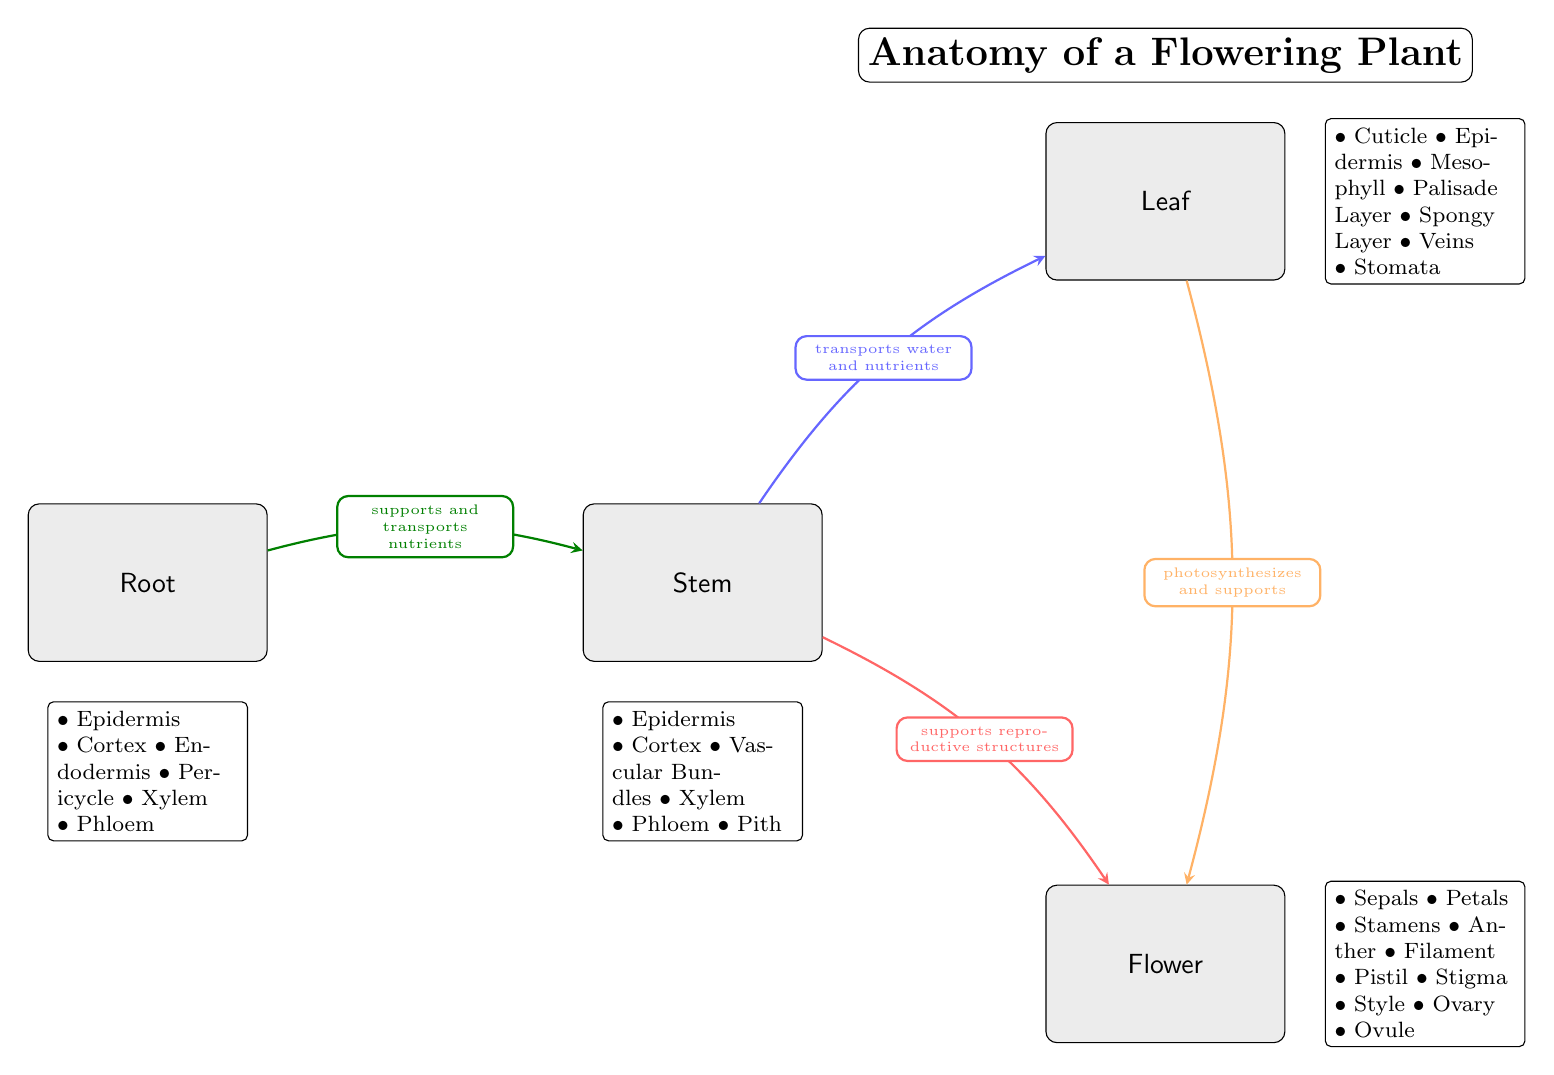What are the main structures of a flowering plant shown in the diagram? The diagram contains four main structures labeled as follows: Root, Stem, Leaf, and Flower. Each of these nodes is distinct and clearly labeled, which indicates their primary functions in the plant anatomy.
Answer: Root, Stem, Leaf, Flower Which structure is responsible for supporting reproductive structures? The arrow from the Stem node pointing towards the Flower node indicates that the Stem supports the Flower, which is where reproductive structures are located. This relationship is clearly labeled in the diagram.
Answer: Stem How many details are listed under the Leaf structure? Under the Leaf structure, there are seven details listed: Cuticle, Epidermis, Mesophyll, Palisade Layer, Spongy Layer, Veins, and Stomata. Counting these points provides the answer.
Answer: 7 What does the arrow from Leaf to Flower indicate about their relationship? The arrow from the Leaf to the Flower is labeled "photosynthesizes and supports," signifying that the Leaf not only conducts photosynthesis but also provides support to the Flower, indicating a functional relationship between these structures.
Answer: photosynthesizes and supports Which layer is found in both the Root and the Stem structures? The details under both the Root and Stem structures list the Epidermis and the presence of Xylem and Phloem, but focusing on a single layer that is mentioned in both lists leads to the answer: Epidermis.
Answer: Epidermis What is the function of Xylem according to the diagram? The diagram shows arrows and labels that highlight the roles of various plant parts. Xylem is mentioned in both the Root and Stem structures, indicating its function in transporting water and nutrients within the plant.
Answer: transports water and nutrients How many reproductive structures are identified under the Flower? Under the Flower structure, there are several reproductive components: Sepals, Petals, Stamens (including Anther, Filament), and Pistil (including Stigma, Style, Ovary, Ovule). Counting these gives the total number of these reproductive structures.
Answer: 9 Which part of the plant is primarily responsible for nutrient absorption? Looking at the details listed under the Root structure, it mentions several layers, and the function of the entire root system is primarily to absorb water and nutrients from the soil. Hence, the answer is clear.
Answer: Root 